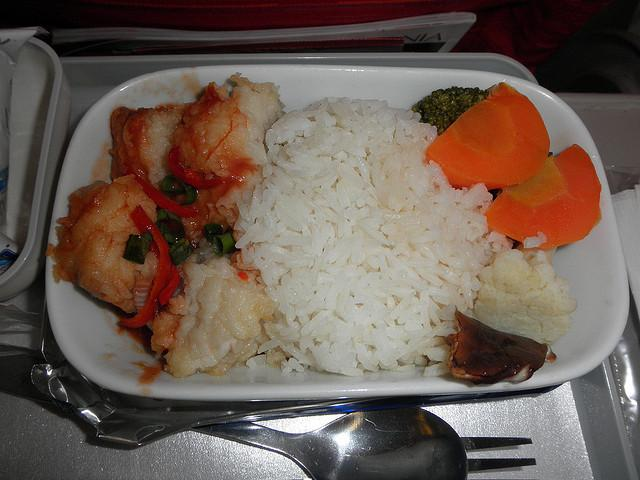On which plant does the vegetable that is reddest here grow?

Choices:
A) cauliflower
B) carrot
C) pepper
D) corn pepper 